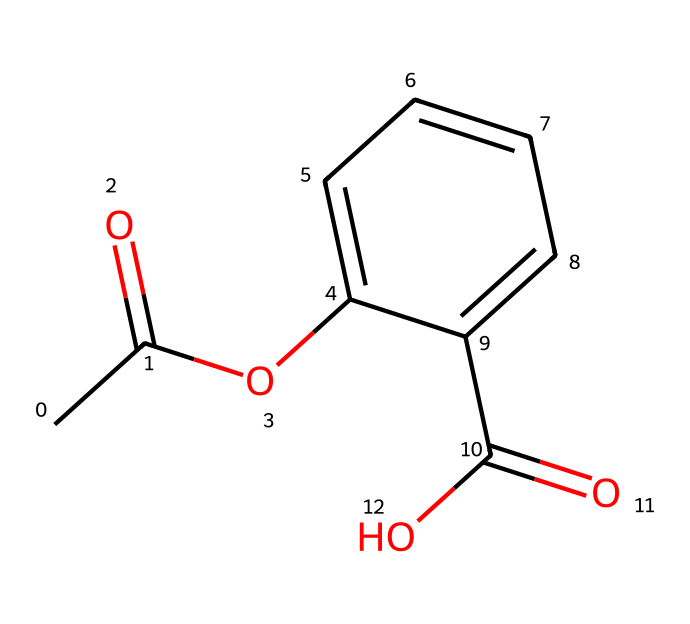How many carbon atoms are present in acetylsalicylic acid? The SMILES representation shows the structure and indicates the presence of 9 carbon atoms, which can be counted from the carbon atoms in the acetyl group (CC=O) and the benzene ring structure (C1=CC=CC=C1).
Answer: 9 What is the functional group that characterizes acetylsalicylic acid? In the SMILES representation, the ester group (OC) linked to a carbonyl (C=O) is present, as well as the carboxylic acid group (C(=O)O). Together, these indicate that acetylsalicylic acid contains both an ester and a carboxylic acid functional group.
Answer: ester and carboxylic acid What is the degree of unsaturation in acetylsalicylic acid? The degree of unsaturation can be calculated based on the number of rings and double bonds present. In the structure, there is one benzene ring and two double bonds, resulting in a total of 4 degrees of unsaturation (one from the benzene and three from the carbonyl and the two double bonds).
Answer: 4 Which part of the structure is responsible for its anti-inflammatory properties? The carboxylic acid group (C(=O)O) in the structure is known to be chemically reactive and contributes to its ability to inhibit cyclooxygenase enzymes, thus providing anti-inflammatory effects.
Answer: carboxylic acid group There is a carbonyl group in acetylsalicylic acid. How many carbonyls are present? From the SMILES, we see two carbonyl representations: one in the acetyl group (CC(=O)) and another in the carboxylic acid (C(=O)O). Thus, there are two carbonyl groups in the structure.
Answer: 2 What is the molecular formula derived from the structural formula? Counting the various atoms in the structure (9 carbons, 8 hydrogens, 4 oxygens) gives the molecular formula C9H8O4 for acetylsalicylic acid.
Answer: C9H8O4 